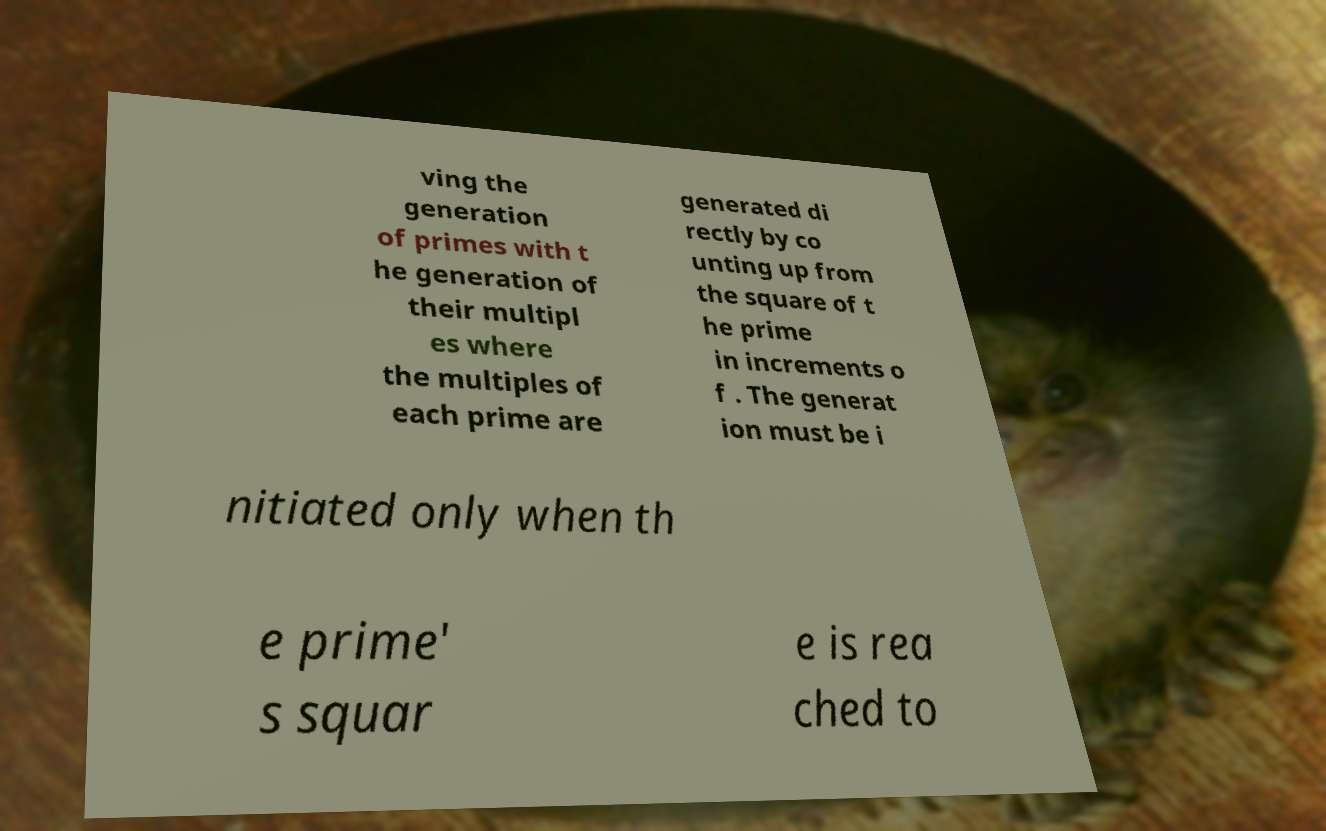Could you extract and type out the text from this image? ving the generation of primes with t he generation of their multipl es where the multiples of each prime are generated di rectly by co unting up from the square of t he prime in increments o f . The generat ion must be i nitiated only when th e prime' s squar e is rea ched to 